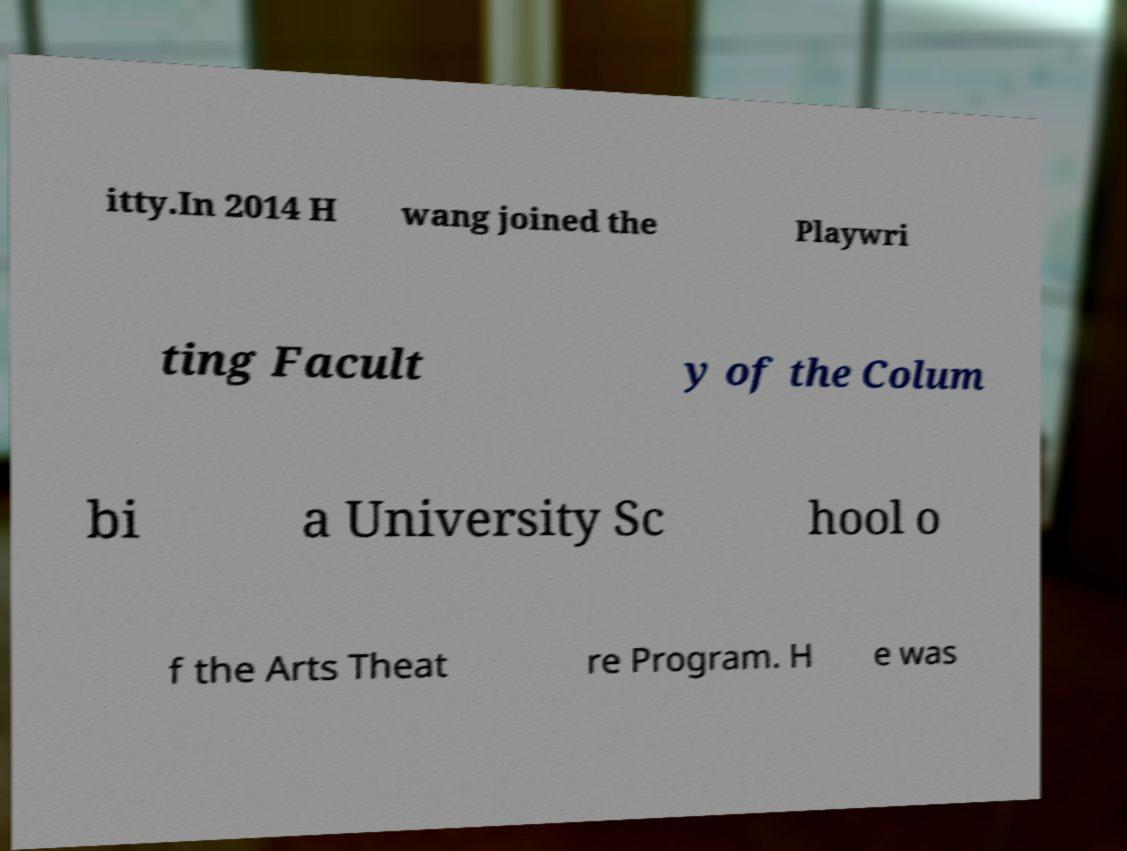Could you extract and type out the text from this image? itty.In 2014 H wang joined the Playwri ting Facult y of the Colum bi a University Sc hool o f the Arts Theat re Program. H e was 